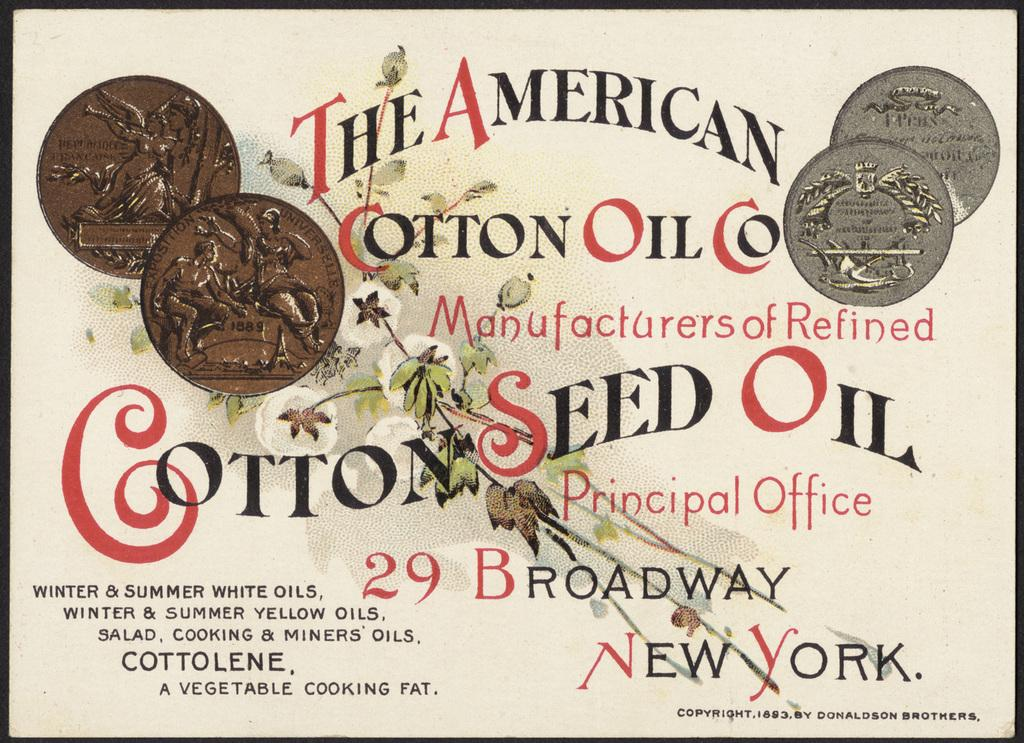Provide a one-sentence caption for the provided image. An advertisement shows the location of the headquarters for The American Cotton Oil Co. 